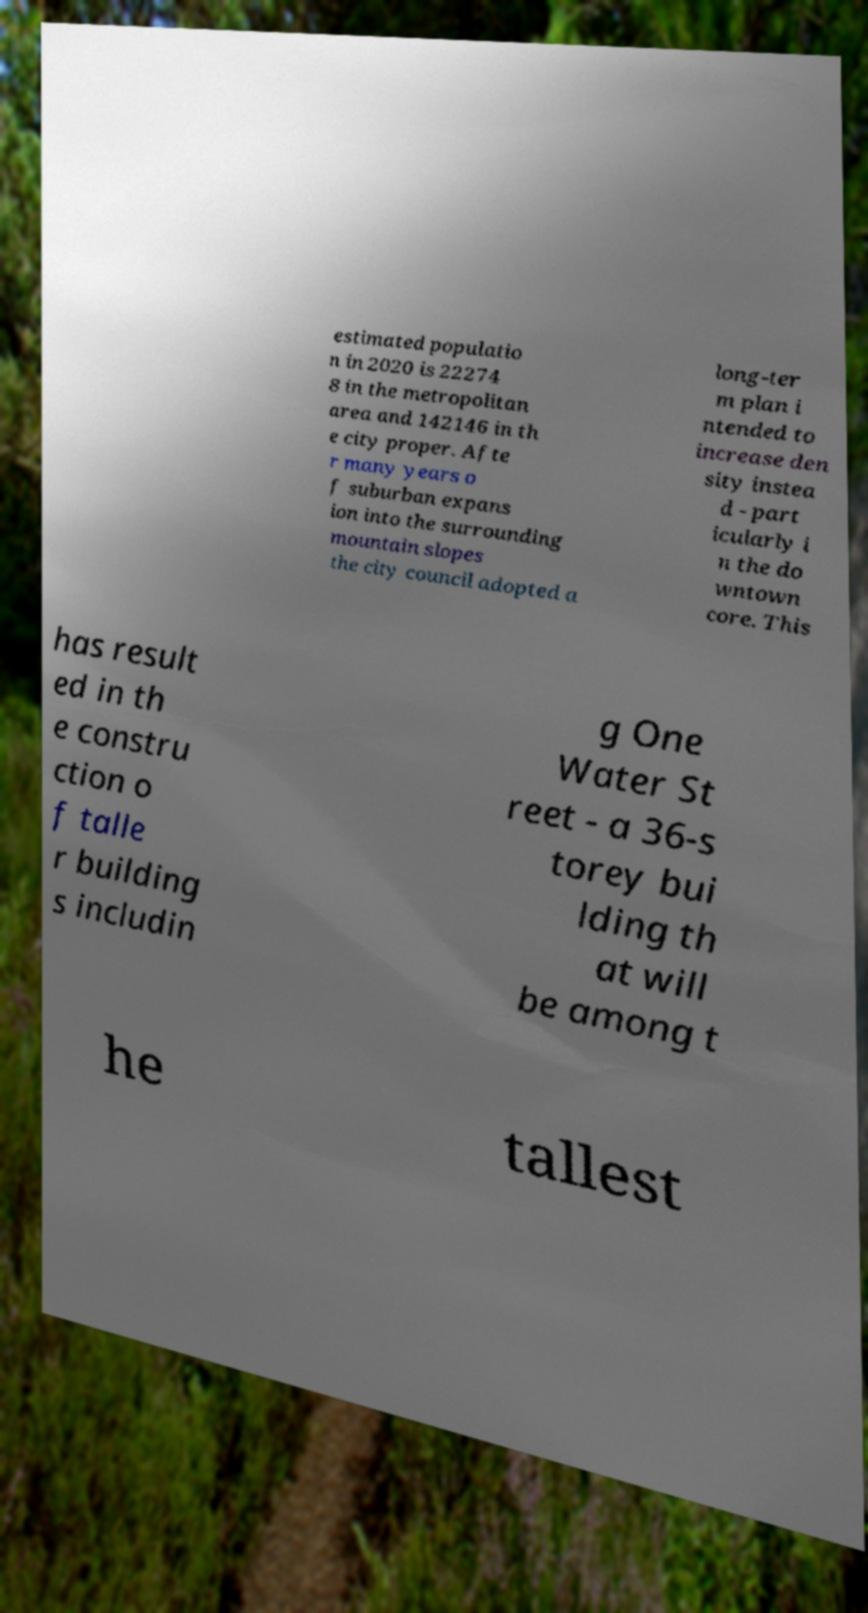Can you read and provide the text displayed in the image?This photo seems to have some interesting text. Can you extract and type it out for me? estimated populatio n in 2020 is 22274 8 in the metropolitan area and 142146 in th e city proper. Afte r many years o f suburban expans ion into the surrounding mountain slopes the city council adopted a long-ter m plan i ntended to increase den sity instea d - part icularly i n the do wntown core. This has result ed in th e constru ction o f talle r building s includin g One Water St reet - a 36-s torey bui lding th at will be among t he tallest 